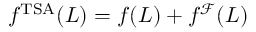<formula> <loc_0><loc_0><loc_500><loc_500>f ^ { T S A } ( L ) = f ( L ) + f ^ { \mathcal { F } } ( L )</formula> 